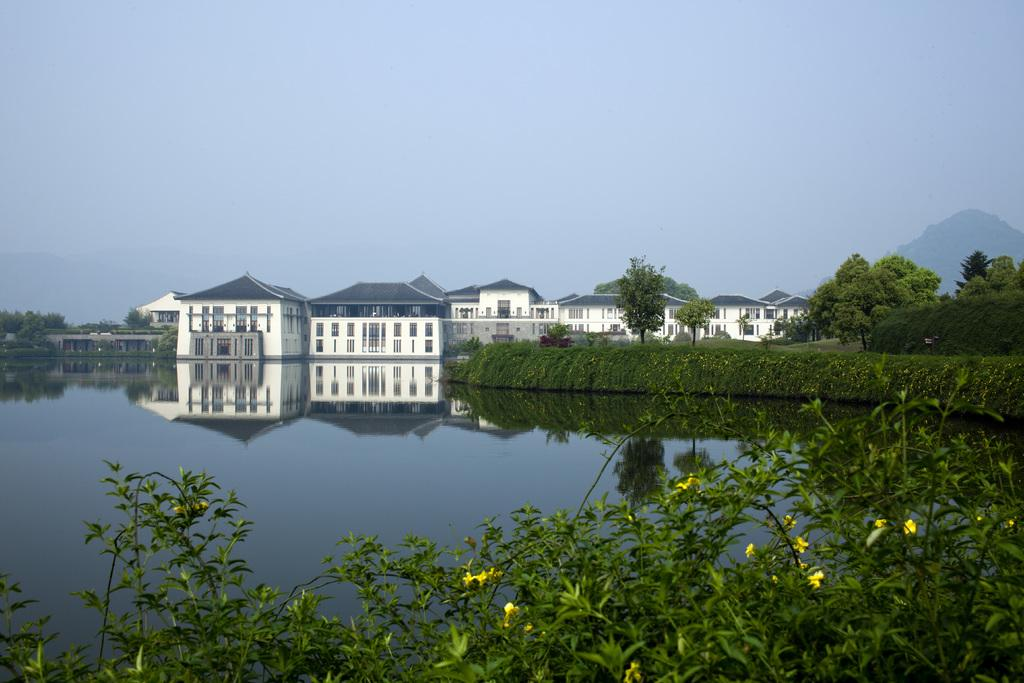What type of vegetation can be seen in the image? There are plants, trees, and flowers visible in the image. What can be seen in the background of the image? There are buildings and water visible in the image. What is visible in the sky in the image? The sky is visible in the image. What type of fuel is being used by the plants in the image? There is no indication of any fuel being used by the plants in the image, as plants produce their own energy through photosynthesis. 